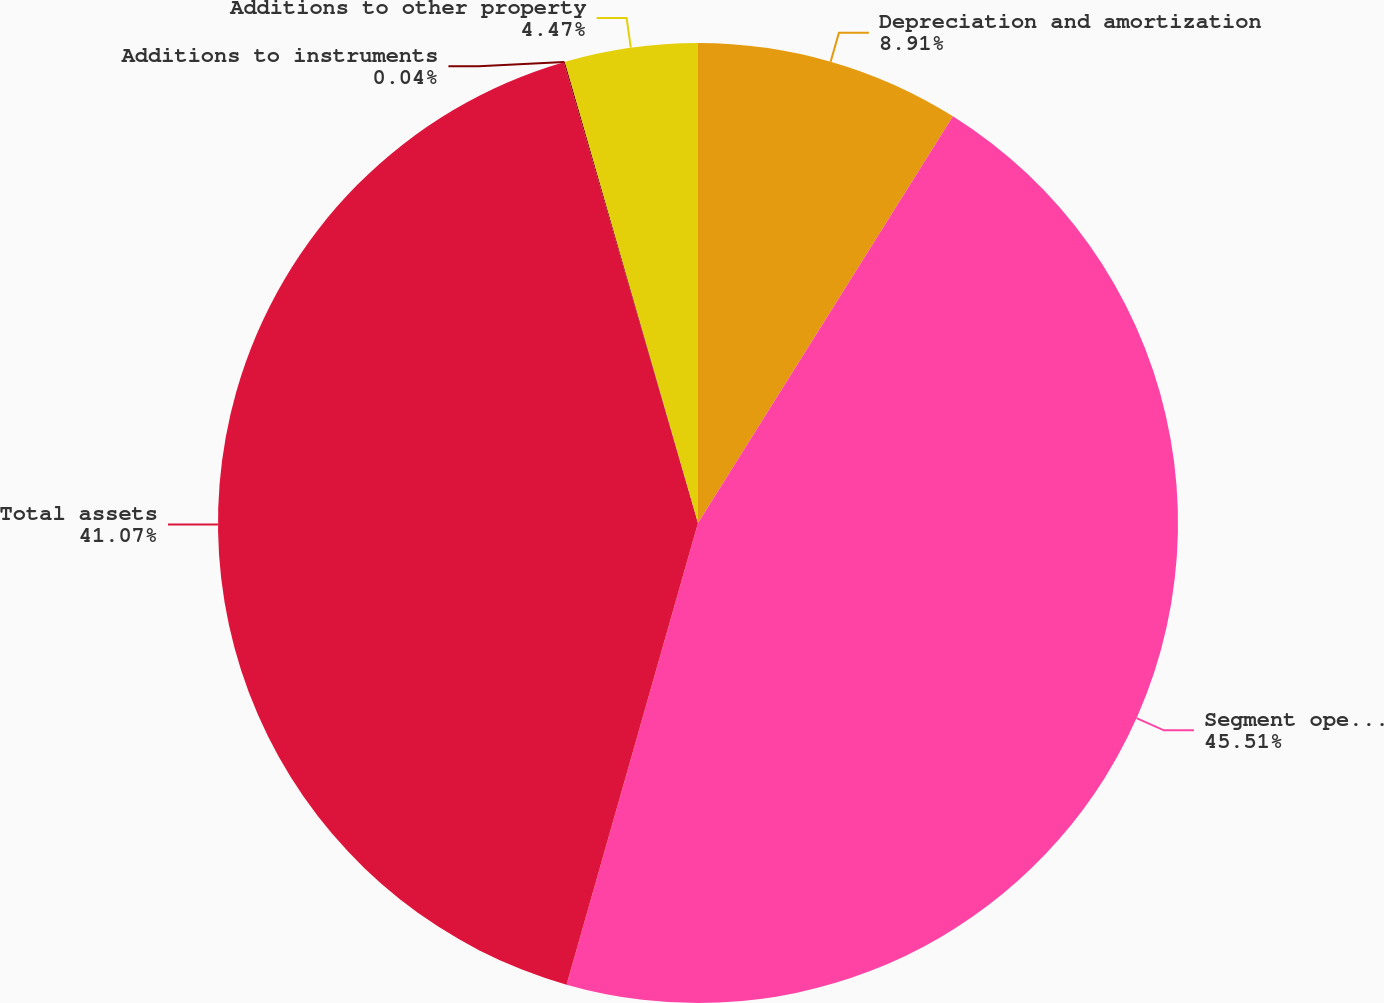Convert chart to OTSL. <chart><loc_0><loc_0><loc_500><loc_500><pie_chart><fcel>Depreciation and amortization<fcel>Segment operating profit<fcel>Total assets<fcel>Additions to instruments<fcel>Additions to other property<nl><fcel>8.91%<fcel>45.5%<fcel>41.07%<fcel>0.04%<fcel>4.47%<nl></chart> 